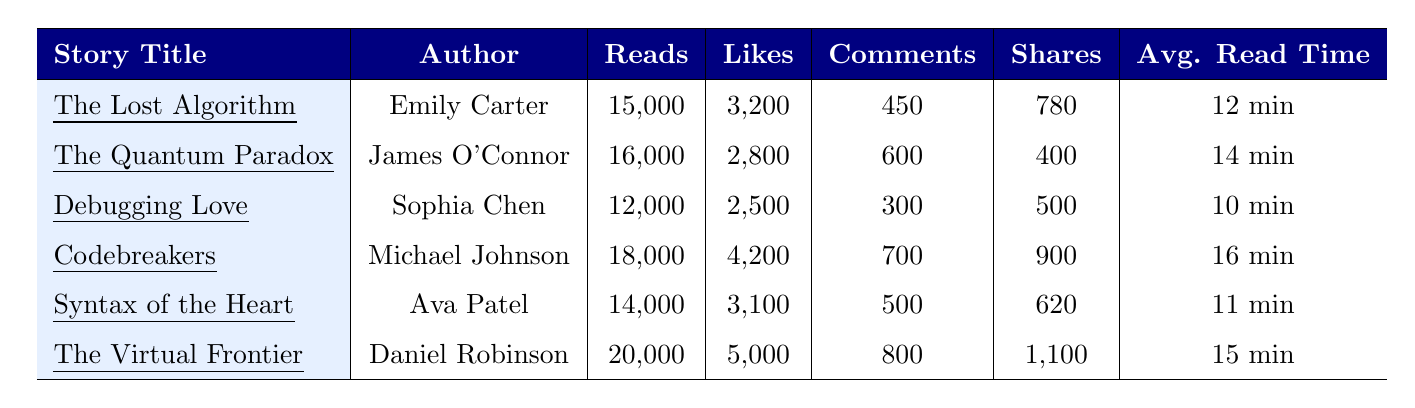What is the story with the highest number of reads? The highest number of reads can be found by comparing the "Reads" column in the table. The story "The Virtual Frontier" has 20,000 reads, which is greater than all other stories listed.
Answer: The Virtual Frontier Which story has the lowest number of likes? To find the lowest number of likes, we observe the "Likes" column. "Debugging Love" has the least likes with 2,500.
Answer: Debugging Love What is the total number of comments across all stories? We calculate the total comments by summing the "Comments" column: 450 + 600 + 300 + 700 + 500 + 800 = 3350.
Answer: 3350 Which author wrote "Codebreakers"? The "Author" column indicates that "Codebreakers" is written by Michael Johnson.
Answer: Michael Johnson What is the average read time for all stories combined? To find the average read time, sum up all the average read times: 12 + 14 + 10 + 16 + 11 + 15 = 78. Then divide by the number of stories (6): 78 / 6 = 13.
Answer: 13 minutes Which story has more likes, "Syntax of the Heart" or "The Quantum Paradox"? In the "Likes" column, "Syntax of the Heart" has 3,100 likes and "The Quantum Paradox" has 2,800. Comparing these values, "Syntax of the Heart" has more likes.
Answer: Syntax of the Heart How many more shares does "The Virtual Frontier" have than "Debugging Love"? To determine this, we find the difference between the shares for these two stories: 1,100 (for "The Virtual Frontier") - 500 (for "Debugging Love") = 600 more shares.
Answer: 600 more shares Is the average read time for "The Quantum Paradox" greater than the overall average read time? The average read time for "The Quantum Paradox" is 14 minutes which we already calculated the overall average as 13 minutes. Since 14 is greater than 13, the statement is true.
Answer: Yes What is the total number of reads for stories written by authors with the last name "Chen" or "Patel"? We find the stories: "Debugging Love" by Sophia Chen (12,000 reads) and "Syntax of the Heart" by Ava Patel (14,000 reads). The total reads = 12,000 + 14,000 = 26,000.
Answer: 26,000 Which story has the most likes and what is the number of likes? Looking at the "Likes" column, "The Virtual Frontier" has the most likes with 5,000 likes, compared to other stories.
Answer: The Virtual Frontier, 5000 Which two stories combined have the most reads? We check which two stories on the list, when combined, yield the highest sum. "The Virtual Frontier" (20,000) and "Codebreakers" (18,000) total = 38,000 reads.
Answer: 38,000 